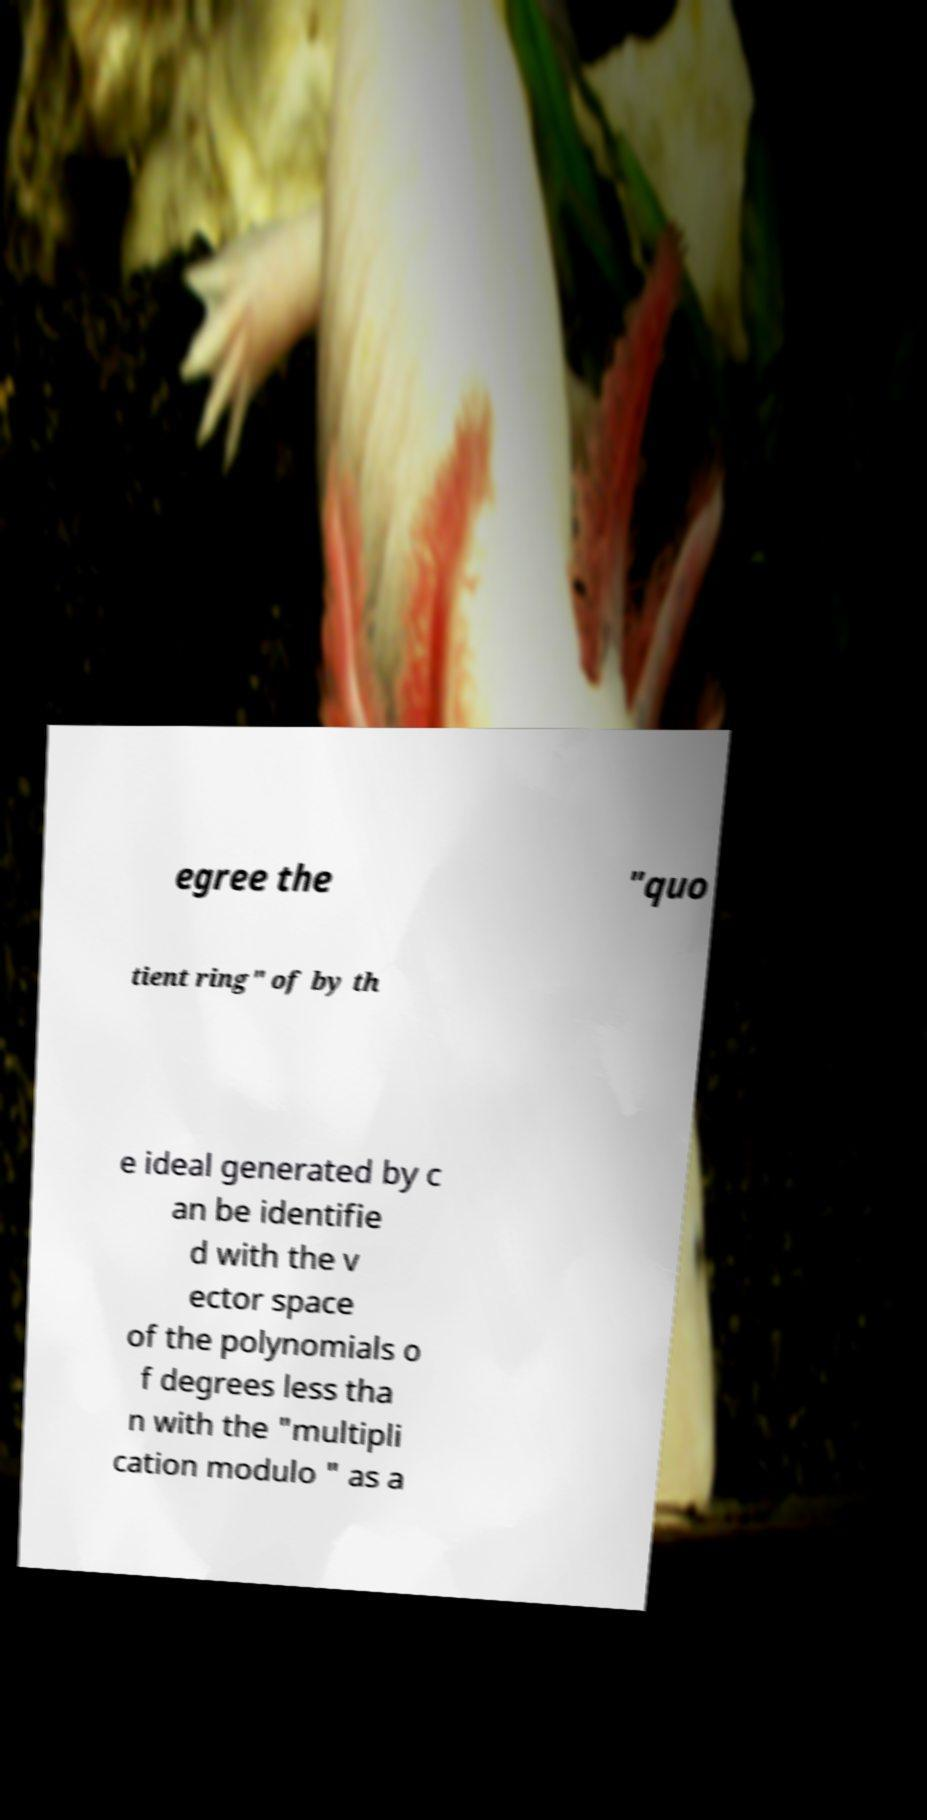Can you read and provide the text displayed in the image?This photo seems to have some interesting text. Can you extract and type it out for me? egree the "quo tient ring" of by th e ideal generated by c an be identifie d with the v ector space of the polynomials o f degrees less tha n with the "multipli cation modulo " as a 